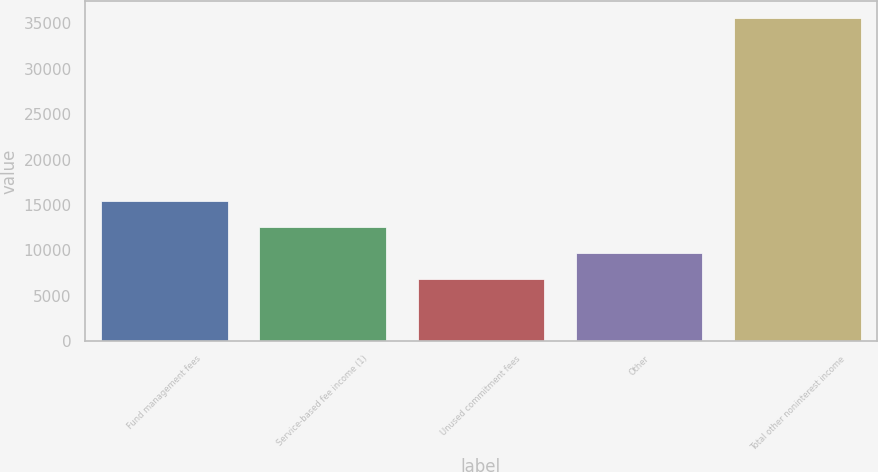Convert chart to OTSL. <chart><loc_0><loc_0><loc_500><loc_500><bar_chart><fcel>Fund management fees<fcel>Service-based fee income (1)<fcel>Unused commitment fees<fcel>Other<fcel>Total other noninterest income<nl><fcel>15475.7<fcel>12594.8<fcel>6833<fcel>9713.9<fcel>35642<nl></chart> 